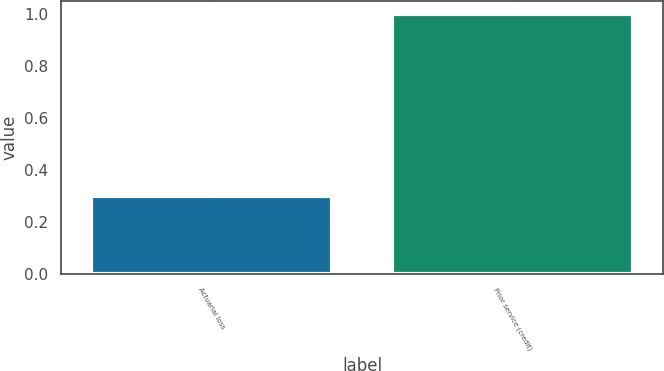Convert chart to OTSL. <chart><loc_0><loc_0><loc_500><loc_500><bar_chart><fcel>Actuarial loss<fcel>Prior service (credit)<nl><fcel>0.3<fcel>1<nl></chart> 